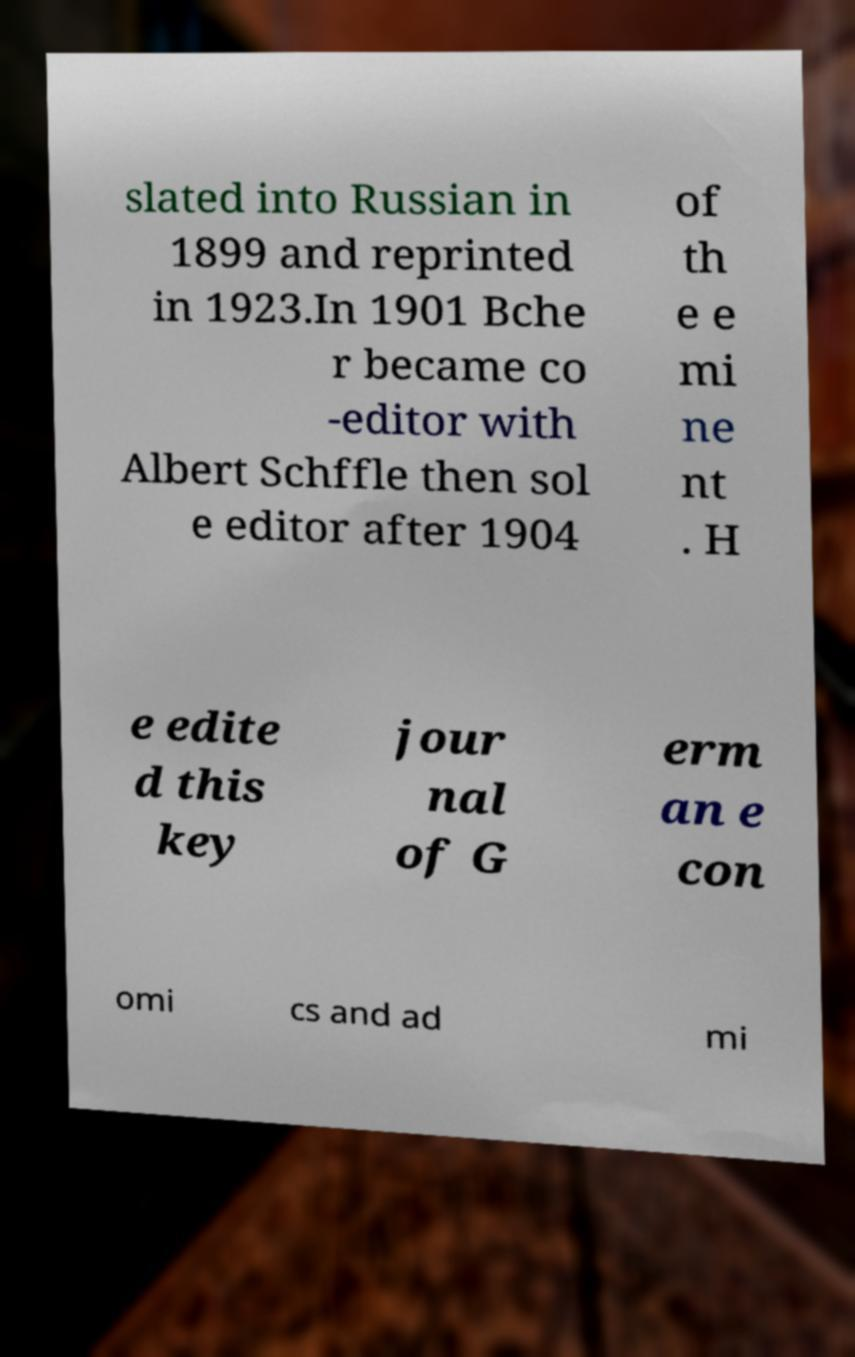Can you read and provide the text displayed in the image?This photo seems to have some interesting text. Can you extract and type it out for me? slated into Russian in 1899 and reprinted in 1923.In 1901 Bche r became co -editor with Albert Schffle then sol e editor after 1904 of th e e mi ne nt . H e edite d this key jour nal of G erm an e con omi cs and ad mi 